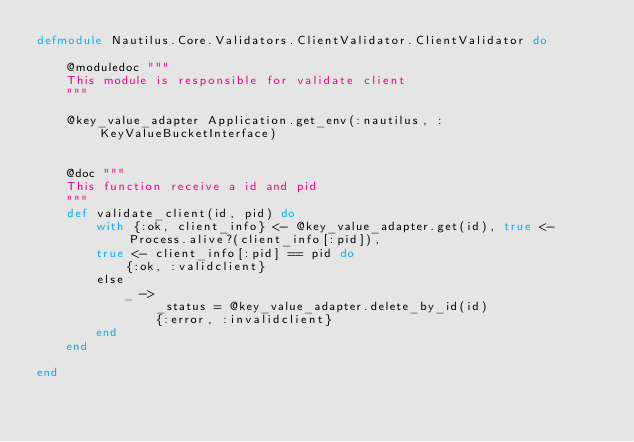Convert code to text. <code><loc_0><loc_0><loc_500><loc_500><_Elixir_>defmodule Nautilus.Core.Validators.ClientValidator.ClientValidator do

    @moduledoc """
    This module is responsible for validate client
    """

    @key_value_adapter Application.get_env(:nautilus, :KeyValueBucketInterface)


    @doc """
    This function receive a id and pid
    """
    def validate_client(id, pid) do
        with {:ok, client_info} <- @key_value_adapter.get(id), true <- Process.alive?(client_info[:pid]),
        true <- client_info[:pid] == pid do
            {:ok, :validclient}
        else
            _ ->
                _status = @key_value_adapter.delete_by_id(id)
                {:error, :invalidclient}
        end
    end

end
</code> 